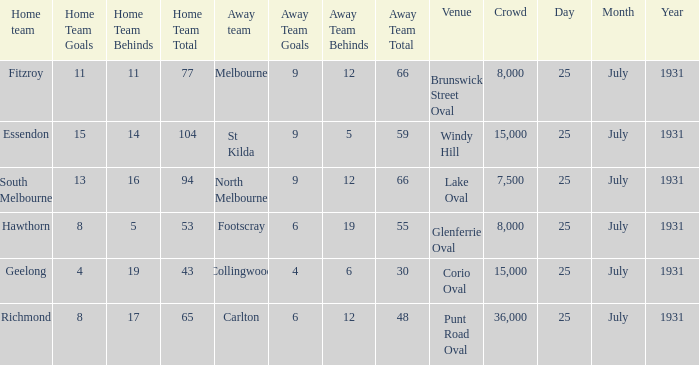When the home team was fitzroy, what did the away team score? 9.12 (66). 